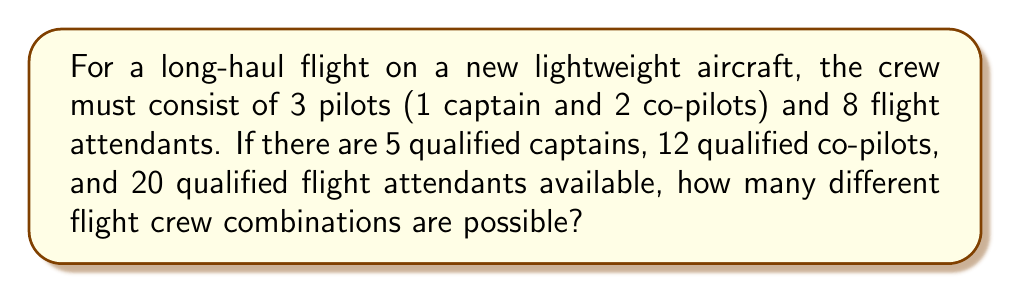Can you answer this question? Let's break this down step-by-step:

1) First, we need to choose the captain:
   There are 5 qualified captains, so we have 5 choices.

2) Next, we need to choose 2 co-pilots from the remaining 12:
   This is a combination problem, represented as $\binom{12}{2}$ or $C(12,2)$
   $$\binom{12}{2} = \frac{12!}{2!(12-2)!} = \frac{12!}{2!10!} = 66$$

3) Finally, we need to choose 8 flight attendants from 20:
   This is another combination, $\binom{20}{8}$ or $C(20,8)$
   $$\binom{20}{8} = \frac{20!}{8!(20-8)!} = \frac{20!}{8!12!} = 125,970$$

4) By the multiplication principle, the total number of possible combinations is:
   $$5 \times 66 \times 125,970$$

5) Calculating this:
   $$5 \times 66 \times 125,970 = 41,570,100$$

Therefore, there are 41,570,100 possible flight crew combinations.
Answer: 41,570,100 